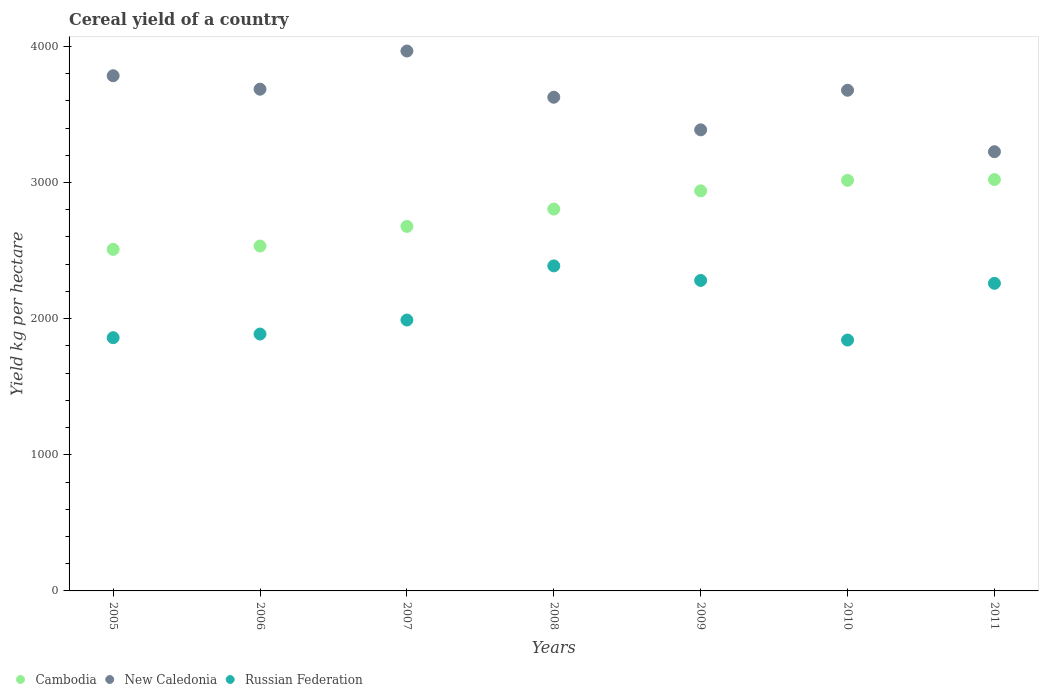What is the total cereal yield in New Caledonia in 2006?
Offer a very short reply. 3685.22. Across all years, what is the maximum total cereal yield in Cambodia?
Offer a terse response. 3021.52. Across all years, what is the minimum total cereal yield in Cambodia?
Provide a succinct answer. 2508.66. What is the total total cereal yield in Russian Federation in the graph?
Keep it short and to the point. 1.45e+04. What is the difference between the total cereal yield in New Caledonia in 2005 and that in 2011?
Offer a very short reply. 557.94. What is the difference between the total cereal yield in Russian Federation in 2006 and the total cereal yield in New Caledonia in 2011?
Your answer should be very brief. -1339.14. What is the average total cereal yield in New Caledonia per year?
Your response must be concise. 3621.57. In the year 2007, what is the difference between the total cereal yield in Cambodia and total cereal yield in Russian Federation?
Keep it short and to the point. 687.45. What is the ratio of the total cereal yield in Russian Federation in 2006 to that in 2010?
Provide a short and direct response. 1.02. Is the difference between the total cereal yield in Cambodia in 2006 and 2009 greater than the difference between the total cereal yield in Russian Federation in 2006 and 2009?
Keep it short and to the point. No. What is the difference between the highest and the second highest total cereal yield in Russian Federation?
Your answer should be compact. 106.78. What is the difference between the highest and the lowest total cereal yield in Russian Federation?
Offer a terse response. 544.64. Is the sum of the total cereal yield in New Caledonia in 2009 and 2010 greater than the maximum total cereal yield in Russian Federation across all years?
Provide a succinct answer. Yes. Is it the case that in every year, the sum of the total cereal yield in New Caledonia and total cereal yield in Cambodia  is greater than the total cereal yield in Russian Federation?
Your answer should be compact. Yes. How many years are there in the graph?
Make the answer very short. 7. Does the graph contain any zero values?
Make the answer very short. No. Does the graph contain grids?
Offer a very short reply. No. Where does the legend appear in the graph?
Your answer should be very brief. Bottom left. How many legend labels are there?
Provide a short and direct response. 3. How are the legend labels stacked?
Keep it short and to the point. Horizontal. What is the title of the graph?
Keep it short and to the point. Cereal yield of a country. What is the label or title of the X-axis?
Your answer should be compact. Years. What is the label or title of the Y-axis?
Provide a short and direct response. Yield kg per hectare. What is the Yield kg per hectare of Cambodia in 2005?
Provide a succinct answer. 2508.66. What is the Yield kg per hectare in New Caledonia in 2005?
Your answer should be compact. 3783.94. What is the Yield kg per hectare in Russian Federation in 2005?
Your answer should be compact. 1860.17. What is the Yield kg per hectare in Cambodia in 2006?
Give a very brief answer. 2533.1. What is the Yield kg per hectare in New Caledonia in 2006?
Offer a very short reply. 3685.22. What is the Yield kg per hectare of Russian Federation in 2006?
Give a very brief answer. 1886.86. What is the Yield kg per hectare in Cambodia in 2007?
Offer a very short reply. 2677.25. What is the Yield kg per hectare of New Caledonia in 2007?
Provide a succinct answer. 3965.54. What is the Yield kg per hectare of Russian Federation in 2007?
Offer a very short reply. 1989.8. What is the Yield kg per hectare in Cambodia in 2008?
Provide a short and direct response. 2804.76. What is the Yield kg per hectare in New Caledonia in 2008?
Your answer should be compact. 3626.16. What is the Yield kg per hectare of Russian Federation in 2008?
Give a very brief answer. 2387.33. What is the Yield kg per hectare of Cambodia in 2009?
Your answer should be very brief. 2938.61. What is the Yield kg per hectare in New Caledonia in 2009?
Your answer should be compact. 3386.68. What is the Yield kg per hectare in Russian Federation in 2009?
Your response must be concise. 2280.55. What is the Yield kg per hectare in Cambodia in 2010?
Provide a short and direct response. 3015.74. What is the Yield kg per hectare in New Caledonia in 2010?
Keep it short and to the point. 3677.45. What is the Yield kg per hectare of Russian Federation in 2010?
Offer a terse response. 1842.69. What is the Yield kg per hectare in Cambodia in 2011?
Keep it short and to the point. 3021.52. What is the Yield kg per hectare of New Caledonia in 2011?
Ensure brevity in your answer.  3226. What is the Yield kg per hectare of Russian Federation in 2011?
Your answer should be compact. 2259.34. Across all years, what is the maximum Yield kg per hectare of Cambodia?
Offer a very short reply. 3021.52. Across all years, what is the maximum Yield kg per hectare of New Caledonia?
Provide a succinct answer. 3965.54. Across all years, what is the maximum Yield kg per hectare of Russian Federation?
Give a very brief answer. 2387.33. Across all years, what is the minimum Yield kg per hectare of Cambodia?
Give a very brief answer. 2508.66. Across all years, what is the minimum Yield kg per hectare in New Caledonia?
Your answer should be compact. 3226. Across all years, what is the minimum Yield kg per hectare in Russian Federation?
Offer a terse response. 1842.69. What is the total Yield kg per hectare in Cambodia in the graph?
Provide a succinct answer. 1.95e+04. What is the total Yield kg per hectare of New Caledonia in the graph?
Your answer should be very brief. 2.54e+04. What is the total Yield kg per hectare in Russian Federation in the graph?
Offer a very short reply. 1.45e+04. What is the difference between the Yield kg per hectare of Cambodia in 2005 and that in 2006?
Provide a short and direct response. -24.45. What is the difference between the Yield kg per hectare in New Caledonia in 2005 and that in 2006?
Offer a very short reply. 98.72. What is the difference between the Yield kg per hectare in Russian Federation in 2005 and that in 2006?
Provide a short and direct response. -26.69. What is the difference between the Yield kg per hectare of Cambodia in 2005 and that in 2007?
Your response must be concise. -168.6. What is the difference between the Yield kg per hectare in New Caledonia in 2005 and that in 2007?
Offer a very short reply. -181.6. What is the difference between the Yield kg per hectare of Russian Federation in 2005 and that in 2007?
Keep it short and to the point. -129.64. What is the difference between the Yield kg per hectare in Cambodia in 2005 and that in 2008?
Your response must be concise. -296.11. What is the difference between the Yield kg per hectare of New Caledonia in 2005 and that in 2008?
Offer a very short reply. 157.78. What is the difference between the Yield kg per hectare in Russian Federation in 2005 and that in 2008?
Offer a very short reply. -527.16. What is the difference between the Yield kg per hectare of Cambodia in 2005 and that in 2009?
Keep it short and to the point. -429.96. What is the difference between the Yield kg per hectare of New Caledonia in 2005 and that in 2009?
Make the answer very short. 397.26. What is the difference between the Yield kg per hectare of Russian Federation in 2005 and that in 2009?
Offer a very short reply. -420.38. What is the difference between the Yield kg per hectare of Cambodia in 2005 and that in 2010?
Your answer should be compact. -507.08. What is the difference between the Yield kg per hectare of New Caledonia in 2005 and that in 2010?
Provide a succinct answer. 106.49. What is the difference between the Yield kg per hectare in Russian Federation in 2005 and that in 2010?
Offer a terse response. 17.47. What is the difference between the Yield kg per hectare in Cambodia in 2005 and that in 2011?
Provide a succinct answer. -512.87. What is the difference between the Yield kg per hectare of New Caledonia in 2005 and that in 2011?
Offer a terse response. 557.94. What is the difference between the Yield kg per hectare in Russian Federation in 2005 and that in 2011?
Provide a succinct answer. -399.17. What is the difference between the Yield kg per hectare in Cambodia in 2006 and that in 2007?
Provide a succinct answer. -144.15. What is the difference between the Yield kg per hectare in New Caledonia in 2006 and that in 2007?
Make the answer very short. -280.32. What is the difference between the Yield kg per hectare in Russian Federation in 2006 and that in 2007?
Give a very brief answer. -102.95. What is the difference between the Yield kg per hectare in Cambodia in 2006 and that in 2008?
Ensure brevity in your answer.  -271.66. What is the difference between the Yield kg per hectare in New Caledonia in 2006 and that in 2008?
Offer a terse response. 59.06. What is the difference between the Yield kg per hectare of Russian Federation in 2006 and that in 2008?
Your response must be concise. -500.47. What is the difference between the Yield kg per hectare in Cambodia in 2006 and that in 2009?
Offer a very short reply. -405.51. What is the difference between the Yield kg per hectare in New Caledonia in 2006 and that in 2009?
Offer a very short reply. 298.54. What is the difference between the Yield kg per hectare in Russian Federation in 2006 and that in 2009?
Offer a terse response. -393.69. What is the difference between the Yield kg per hectare of Cambodia in 2006 and that in 2010?
Keep it short and to the point. -482.64. What is the difference between the Yield kg per hectare of New Caledonia in 2006 and that in 2010?
Provide a short and direct response. 7.76. What is the difference between the Yield kg per hectare of Russian Federation in 2006 and that in 2010?
Your answer should be very brief. 44.16. What is the difference between the Yield kg per hectare in Cambodia in 2006 and that in 2011?
Offer a terse response. -488.42. What is the difference between the Yield kg per hectare of New Caledonia in 2006 and that in 2011?
Provide a short and direct response. 459.22. What is the difference between the Yield kg per hectare of Russian Federation in 2006 and that in 2011?
Keep it short and to the point. -372.48. What is the difference between the Yield kg per hectare in Cambodia in 2007 and that in 2008?
Keep it short and to the point. -127.51. What is the difference between the Yield kg per hectare in New Caledonia in 2007 and that in 2008?
Offer a very short reply. 339.38. What is the difference between the Yield kg per hectare of Russian Federation in 2007 and that in 2008?
Provide a short and direct response. -397.53. What is the difference between the Yield kg per hectare of Cambodia in 2007 and that in 2009?
Offer a terse response. -261.36. What is the difference between the Yield kg per hectare of New Caledonia in 2007 and that in 2009?
Your answer should be compact. 578.86. What is the difference between the Yield kg per hectare of Russian Federation in 2007 and that in 2009?
Keep it short and to the point. -290.75. What is the difference between the Yield kg per hectare in Cambodia in 2007 and that in 2010?
Offer a very short reply. -338.49. What is the difference between the Yield kg per hectare in New Caledonia in 2007 and that in 2010?
Provide a succinct answer. 288.09. What is the difference between the Yield kg per hectare of Russian Federation in 2007 and that in 2010?
Provide a short and direct response. 147.11. What is the difference between the Yield kg per hectare of Cambodia in 2007 and that in 2011?
Provide a short and direct response. -344.27. What is the difference between the Yield kg per hectare of New Caledonia in 2007 and that in 2011?
Keep it short and to the point. 739.54. What is the difference between the Yield kg per hectare in Russian Federation in 2007 and that in 2011?
Provide a short and direct response. -269.53. What is the difference between the Yield kg per hectare in Cambodia in 2008 and that in 2009?
Keep it short and to the point. -133.85. What is the difference between the Yield kg per hectare of New Caledonia in 2008 and that in 2009?
Provide a short and direct response. 239.48. What is the difference between the Yield kg per hectare in Russian Federation in 2008 and that in 2009?
Your answer should be very brief. 106.78. What is the difference between the Yield kg per hectare in Cambodia in 2008 and that in 2010?
Your answer should be very brief. -210.98. What is the difference between the Yield kg per hectare in New Caledonia in 2008 and that in 2010?
Provide a short and direct response. -51.29. What is the difference between the Yield kg per hectare in Russian Federation in 2008 and that in 2010?
Your answer should be compact. 544.64. What is the difference between the Yield kg per hectare in Cambodia in 2008 and that in 2011?
Offer a terse response. -216.76. What is the difference between the Yield kg per hectare of New Caledonia in 2008 and that in 2011?
Your answer should be compact. 400.16. What is the difference between the Yield kg per hectare of Russian Federation in 2008 and that in 2011?
Provide a succinct answer. 127.99. What is the difference between the Yield kg per hectare of Cambodia in 2009 and that in 2010?
Make the answer very short. -77.13. What is the difference between the Yield kg per hectare of New Caledonia in 2009 and that in 2010?
Offer a very short reply. -290.77. What is the difference between the Yield kg per hectare of Russian Federation in 2009 and that in 2010?
Give a very brief answer. 437.86. What is the difference between the Yield kg per hectare in Cambodia in 2009 and that in 2011?
Your answer should be compact. -82.91. What is the difference between the Yield kg per hectare in New Caledonia in 2009 and that in 2011?
Offer a very short reply. 160.68. What is the difference between the Yield kg per hectare in Russian Federation in 2009 and that in 2011?
Your response must be concise. 21.21. What is the difference between the Yield kg per hectare of Cambodia in 2010 and that in 2011?
Keep it short and to the point. -5.78. What is the difference between the Yield kg per hectare of New Caledonia in 2010 and that in 2011?
Your answer should be very brief. 451.45. What is the difference between the Yield kg per hectare of Russian Federation in 2010 and that in 2011?
Your answer should be very brief. -416.64. What is the difference between the Yield kg per hectare of Cambodia in 2005 and the Yield kg per hectare of New Caledonia in 2006?
Offer a very short reply. -1176.56. What is the difference between the Yield kg per hectare in Cambodia in 2005 and the Yield kg per hectare in Russian Federation in 2006?
Offer a very short reply. 621.8. What is the difference between the Yield kg per hectare in New Caledonia in 2005 and the Yield kg per hectare in Russian Federation in 2006?
Your answer should be very brief. 1897.09. What is the difference between the Yield kg per hectare of Cambodia in 2005 and the Yield kg per hectare of New Caledonia in 2007?
Your response must be concise. -1456.88. What is the difference between the Yield kg per hectare of Cambodia in 2005 and the Yield kg per hectare of Russian Federation in 2007?
Give a very brief answer. 518.85. What is the difference between the Yield kg per hectare of New Caledonia in 2005 and the Yield kg per hectare of Russian Federation in 2007?
Your answer should be compact. 1794.14. What is the difference between the Yield kg per hectare of Cambodia in 2005 and the Yield kg per hectare of New Caledonia in 2008?
Your answer should be compact. -1117.5. What is the difference between the Yield kg per hectare of Cambodia in 2005 and the Yield kg per hectare of Russian Federation in 2008?
Make the answer very short. 121.33. What is the difference between the Yield kg per hectare in New Caledonia in 2005 and the Yield kg per hectare in Russian Federation in 2008?
Offer a terse response. 1396.61. What is the difference between the Yield kg per hectare of Cambodia in 2005 and the Yield kg per hectare of New Caledonia in 2009?
Make the answer very short. -878.03. What is the difference between the Yield kg per hectare of Cambodia in 2005 and the Yield kg per hectare of Russian Federation in 2009?
Make the answer very short. 228.11. What is the difference between the Yield kg per hectare of New Caledonia in 2005 and the Yield kg per hectare of Russian Federation in 2009?
Offer a very short reply. 1503.39. What is the difference between the Yield kg per hectare of Cambodia in 2005 and the Yield kg per hectare of New Caledonia in 2010?
Your response must be concise. -1168.8. What is the difference between the Yield kg per hectare in Cambodia in 2005 and the Yield kg per hectare in Russian Federation in 2010?
Offer a terse response. 665.96. What is the difference between the Yield kg per hectare in New Caledonia in 2005 and the Yield kg per hectare in Russian Federation in 2010?
Provide a succinct answer. 1941.25. What is the difference between the Yield kg per hectare in Cambodia in 2005 and the Yield kg per hectare in New Caledonia in 2011?
Offer a terse response. -717.35. What is the difference between the Yield kg per hectare of Cambodia in 2005 and the Yield kg per hectare of Russian Federation in 2011?
Give a very brief answer. 249.32. What is the difference between the Yield kg per hectare of New Caledonia in 2005 and the Yield kg per hectare of Russian Federation in 2011?
Give a very brief answer. 1524.61. What is the difference between the Yield kg per hectare in Cambodia in 2006 and the Yield kg per hectare in New Caledonia in 2007?
Give a very brief answer. -1432.44. What is the difference between the Yield kg per hectare of Cambodia in 2006 and the Yield kg per hectare of Russian Federation in 2007?
Your answer should be very brief. 543.3. What is the difference between the Yield kg per hectare in New Caledonia in 2006 and the Yield kg per hectare in Russian Federation in 2007?
Give a very brief answer. 1695.41. What is the difference between the Yield kg per hectare in Cambodia in 2006 and the Yield kg per hectare in New Caledonia in 2008?
Offer a terse response. -1093.06. What is the difference between the Yield kg per hectare in Cambodia in 2006 and the Yield kg per hectare in Russian Federation in 2008?
Give a very brief answer. 145.77. What is the difference between the Yield kg per hectare of New Caledonia in 2006 and the Yield kg per hectare of Russian Federation in 2008?
Keep it short and to the point. 1297.89. What is the difference between the Yield kg per hectare in Cambodia in 2006 and the Yield kg per hectare in New Caledonia in 2009?
Provide a short and direct response. -853.58. What is the difference between the Yield kg per hectare in Cambodia in 2006 and the Yield kg per hectare in Russian Federation in 2009?
Provide a short and direct response. 252.55. What is the difference between the Yield kg per hectare in New Caledonia in 2006 and the Yield kg per hectare in Russian Federation in 2009?
Provide a short and direct response. 1404.67. What is the difference between the Yield kg per hectare in Cambodia in 2006 and the Yield kg per hectare in New Caledonia in 2010?
Provide a short and direct response. -1144.35. What is the difference between the Yield kg per hectare in Cambodia in 2006 and the Yield kg per hectare in Russian Federation in 2010?
Keep it short and to the point. 690.41. What is the difference between the Yield kg per hectare in New Caledonia in 2006 and the Yield kg per hectare in Russian Federation in 2010?
Provide a short and direct response. 1842.53. What is the difference between the Yield kg per hectare of Cambodia in 2006 and the Yield kg per hectare of New Caledonia in 2011?
Your answer should be very brief. -692.9. What is the difference between the Yield kg per hectare in Cambodia in 2006 and the Yield kg per hectare in Russian Federation in 2011?
Keep it short and to the point. 273.76. What is the difference between the Yield kg per hectare of New Caledonia in 2006 and the Yield kg per hectare of Russian Federation in 2011?
Your response must be concise. 1425.88. What is the difference between the Yield kg per hectare in Cambodia in 2007 and the Yield kg per hectare in New Caledonia in 2008?
Make the answer very short. -948.91. What is the difference between the Yield kg per hectare of Cambodia in 2007 and the Yield kg per hectare of Russian Federation in 2008?
Offer a very short reply. 289.92. What is the difference between the Yield kg per hectare in New Caledonia in 2007 and the Yield kg per hectare in Russian Federation in 2008?
Your answer should be compact. 1578.21. What is the difference between the Yield kg per hectare in Cambodia in 2007 and the Yield kg per hectare in New Caledonia in 2009?
Give a very brief answer. -709.43. What is the difference between the Yield kg per hectare of Cambodia in 2007 and the Yield kg per hectare of Russian Federation in 2009?
Give a very brief answer. 396.7. What is the difference between the Yield kg per hectare in New Caledonia in 2007 and the Yield kg per hectare in Russian Federation in 2009?
Your response must be concise. 1684.99. What is the difference between the Yield kg per hectare of Cambodia in 2007 and the Yield kg per hectare of New Caledonia in 2010?
Your response must be concise. -1000.2. What is the difference between the Yield kg per hectare in Cambodia in 2007 and the Yield kg per hectare in Russian Federation in 2010?
Provide a short and direct response. 834.56. What is the difference between the Yield kg per hectare of New Caledonia in 2007 and the Yield kg per hectare of Russian Federation in 2010?
Provide a succinct answer. 2122.85. What is the difference between the Yield kg per hectare in Cambodia in 2007 and the Yield kg per hectare in New Caledonia in 2011?
Your answer should be compact. -548.75. What is the difference between the Yield kg per hectare in Cambodia in 2007 and the Yield kg per hectare in Russian Federation in 2011?
Make the answer very short. 417.92. What is the difference between the Yield kg per hectare of New Caledonia in 2007 and the Yield kg per hectare of Russian Federation in 2011?
Offer a terse response. 1706.2. What is the difference between the Yield kg per hectare of Cambodia in 2008 and the Yield kg per hectare of New Caledonia in 2009?
Your answer should be compact. -581.92. What is the difference between the Yield kg per hectare in Cambodia in 2008 and the Yield kg per hectare in Russian Federation in 2009?
Provide a succinct answer. 524.21. What is the difference between the Yield kg per hectare in New Caledonia in 2008 and the Yield kg per hectare in Russian Federation in 2009?
Provide a succinct answer. 1345.61. What is the difference between the Yield kg per hectare in Cambodia in 2008 and the Yield kg per hectare in New Caledonia in 2010?
Give a very brief answer. -872.69. What is the difference between the Yield kg per hectare of Cambodia in 2008 and the Yield kg per hectare of Russian Federation in 2010?
Keep it short and to the point. 962.07. What is the difference between the Yield kg per hectare of New Caledonia in 2008 and the Yield kg per hectare of Russian Federation in 2010?
Ensure brevity in your answer.  1783.47. What is the difference between the Yield kg per hectare of Cambodia in 2008 and the Yield kg per hectare of New Caledonia in 2011?
Your answer should be very brief. -421.24. What is the difference between the Yield kg per hectare of Cambodia in 2008 and the Yield kg per hectare of Russian Federation in 2011?
Provide a short and direct response. 545.42. What is the difference between the Yield kg per hectare in New Caledonia in 2008 and the Yield kg per hectare in Russian Federation in 2011?
Your response must be concise. 1366.82. What is the difference between the Yield kg per hectare in Cambodia in 2009 and the Yield kg per hectare in New Caledonia in 2010?
Provide a short and direct response. -738.84. What is the difference between the Yield kg per hectare of Cambodia in 2009 and the Yield kg per hectare of Russian Federation in 2010?
Offer a terse response. 1095.92. What is the difference between the Yield kg per hectare in New Caledonia in 2009 and the Yield kg per hectare in Russian Federation in 2010?
Your answer should be compact. 1543.99. What is the difference between the Yield kg per hectare in Cambodia in 2009 and the Yield kg per hectare in New Caledonia in 2011?
Offer a terse response. -287.39. What is the difference between the Yield kg per hectare of Cambodia in 2009 and the Yield kg per hectare of Russian Federation in 2011?
Your answer should be very brief. 679.27. What is the difference between the Yield kg per hectare of New Caledonia in 2009 and the Yield kg per hectare of Russian Federation in 2011?
Provide a short and direct response. 1127.35. What is the difference between the Yield kg per hectare of Cambodia in 2010 and the Yield kg per hectare of New Caledonia in 2011?
Give a very brief answer. -210.26. What is the difference between the Yield kg per hectare in Cambodia in 2010 and the Yield kg per hectare in Russian Federation in 2011?
Provide a succinct answer. 756.4. What is the difference between the Yield kg per hectare of New Caledonia in 2010 and the Yield kg per hectare of Russian Federation in 2011?
Provide a short and direct response. 1418.12. What is the average Yield kg per hectare in Cambodia per year?
Your answer should be compact. 2785.66. What is the average Yield kg per hectare of New Caledonia per year?
Ensure brevity in your answer.  3621.57. What is the average Yield kg per hectare in Russian Federation per year?
Offer a terse response. 2072.39. In the year 2005, what is the difference between the Yield kg per hectare of Cambodia and Yield kg per hectare of New Caledonia?
Provide a succinct answer. -1275.29. In the year 2005, what is the difference between the Yield kg per hectare of Cambodia and Yield kg per hectare of Russian Federation?
Your answer should be very brief. 648.49. In the year 2005, what is the difference between the Yield kg per hectare in New Caledonia and Yield kg per hectare in Russian Federation?
Offer a terse response. 1923.78. In the year 2006, what is the difference between the Yield kg per hectare in Cambodia and Yield kg per hectare in New Caledonia?
Make the answer very short. -1152.12. In the year 2006, what is the difference between the Yield kg per hectare of Cambodia and Yield kg per hectare of Russian Federation?
Offer a terse response. 646.24. In the year 2006, what is the difference between the Yield kg per hectare of New Caledonia and Yield kg per hectare of Russian Federation?
Your response must be concise. 1798.36. In the year 2007, what is the difference between the Yield kg per hectare in Cambodia and Yield kg per hectare in New Caledonia?
Your answer should be very brief. -1288.29. In the year 2007, what is the difference between the Yield kg per hectare in Cambodia and Yield kg per hectare in Russian Federation?
Keep it short and to the point. 687.45. In the year 2007, what is the difference between the Yield kg per hectare in New Caledonia and Yield kg per hectare in Russian Federation?
Ensure brevity in your answer.  1975.74. In the year 2008, what is the difference between the Yield kg per hectare of Cambodia and Yield kg per hectare of New Caledonia?
Provide a short and direct response. -821.4. In the year 2008, what is the difference between the Yield kg per hectare in Cambodia and Yield kg per hectare in Russian Federation?
Make the answer very short. 417.43. In the year 2008, what is the difference between the Yield kg per hectare in New Caledonia and Yield kg per hectare in Russian Federation?
Keep it short and to the point. 1238.83. In the year 2009, what is the difference between the Yield kg per hectare of Cambodia and Yield kg per hectare of New Caledonia?
Your response must be concise. -448.07. In the year 2009, what is the difference between the Yield kg per hectare of Cambodia and Yield kg per hectare of Russian Federation?
Offer a very short reply. 658.06. In the year 2009, what is the difference between the Yield kg per hectare of New Caledonia and Yield kg per hectare of Russian Federation?
Offer a terse response. 1106.13. In the year 2010, what is the difference between the Yield kg per hectare in Cambodia and Yield kg per hectare in New Caledonia?
Make the answer very short. -661.72. In the year 2010, what is the difference between the Yield kg per hectare in Cambodia and Yield kg per hectare in Russian Federation?
Make the answer very short. 1173.05. In the year 2010, what is the difference between the Yield kg per hectare in New Caledonia and Yield kg per hectare in Russian Federation?
Make the answer very short. 1834.76. In the year 2011, what is the difference between the Yield kg per hectare of Cambodia and Yield kg per hectare of New Caledonia?
Give a very brief answer. -204.48. In the year 2011, what is the difference between the Yield kg per hectare of Cambodia and Yield kg per hectare of Russian Federation?
Make the answer very short. 762.18. In the year 2011, what is the difference between the Yield kg per hectare in New Caledonia and Yield kg per hectare in Russian Federation?
Provide a succinct answer. 966.66. What is the ratio of the Yield kg per hectare in Cambodia in 2005 to that in 2006?
Keep it short and to the point. 0.99. What is the ratio of the Yield kg per hectare of New Caledonia in 2005 to that in 2006?
Make the answer very short. 1.03. What is the ratio of the Yield kg per hectare of Russian Federation in 2005 to that in 2006?
Provide a short and direct response. 0.99. What is the ratio of the Yield kg per hectare of Cambodia in 2005 to that in 2007?
Offer a very short reply. 0.94. What is the ratio of the Yield kg per hectare of New Caledonia in 2005 to that in 2007?
Your response must be concise. 0.95. What is the ratio of the Yield kg per hectare of Russian Federation in 2005 to that in 2007?
Make the answer very short. 0.93. What is the ratio of the Yield kg per hectare in Cambodia in 2005 to that in 2008?
Ensure brevity in your answer.  0.89. What is the ratio of the Yield kg per hectare in New Caledonia in 2005 to that in 2008?
Your response must be concise. 1.04. What is the ratio of the Yield kg per hectare in Russian Federation in 2005 to that in 2008?
Offer a terse response. 0.78. What is the ratio of the Yield kg per hectare of Cambodia in 2005 to that in 2009?
Provide a succinct answer. 0.85. What is the ratio of the Yield kg per hectare in New Caledonia in 2005 to that in 2009?
Keep it short and to the point. 1.12. What is the ratio of the Yield kg per hectare in Russian Federation in 2005 to that in 2009?
Your answer should be very brief. 0.82. What is the ratio of the Yield kg per hectare in Cambodia in 2005 to that in 2010?
Your answer should be compact. 0.83. What is the ratio of the Yield kg per hectare in Russian Federation in 2005 to that in 2010?
Offer a terse response. 1.01. What is the ratio of the Yield kg per hectare in Cambodia in 2005 to that in 2011?
Offer a very short reply. 0.83. What is the ratio of the Yield kg per hectare in New Caledonia in 2005 to that in 2011?
Offer a terse response. 1.17. What is the ratio of the Yield kg per hectare of Russian Federation in 2005 to that in 2011?
Offer a terse response. 0.82. What is the ratio of the Yield kg per hectare of Cambodia in 2006 to that in 2007?
Offer a very short reply. 0.95. What is the ratio of the Yield kg per hectare of New Caledonia in 2006 to that in 2007?
Ensure brevity in your answer.  0.93. What is the ratio of the Yield kg per hectare in Russian Federation in 2006 to that in 2007?
Your answer should be very brief. 0.95. What is the ratio of the Yield kg per hectare in Cambodia in 2006 to that in 2008?
Ensure brevity in your answer.  0.9. What is the ratio of the Yield kg per hectare of New Caledonia in 2006 to that in 2008?
Ensure brevity in your answer.  1.02. What is the ratio of the Yield kg per hectare in Russian Federation in 2006 to that in 2008?
Offer a terse response. 0.79. What is the ratio of the Yield kg per hectare in Cambodia in 2006 to that in 2009?
Provide a succinct answer. 0.86. What is the ratio of the Yield kg per hectare of New Caledonia in 2006 to that in 2009?
Make the answer very short. 1.09. What is the ratio of the Yield kg per hectare of Russian Federation in 2006 to that in 2009?
Make the answer very short. 0.83. What is the ratio of the Yield kg per hectare of Cambodia in 2006 to that in 2010?
Give a very brief answer. 0.84. What is the ratio of the Yield kg per hectare in New Caledonia in 2006 to that in 2010?
Your answer should be very brief. 1. What is the ratio of the Yield kg per hectare of Cambodia in 2006 to that in 2011?
Your answer should be very brief. 0.84. What is the ratio of the Yield kg per hectare of New Caledonia in 2006 to that in 2011?
Your answer should be compact. 1.14. What is the ratio of the Yield kg per hectare of Russian Federation in 2006 to that in 2011?
Offer a terse response. 0.84. What is the ratio of the Yield kg per hectare of Cambodia in 2007 to that in 2008?
Provide a succinct answer. 0.95. What is the ratio of the Yield kg per hectare of New Caledonia in 2007 to that in 2008?
Offer a terse response. 1.09. What is the ratio of the Yield kg per hectare of Russian Federation in 2007 to that in 2008?
Make the answer very short. 0.83. What is the ratio of the Yield kg per hectare of Cambodia in 2007 to that in 2009?
Provide a short and direct response. 0.91. What is the ratio of the Yield kg per hectare of New Caledonia in 2007 to that in 2009?
Provide a succinct answer. 1.17. What is the ratio of the Yield kg per hectare in Russian Federation in 2007 to that in 2009?
Make the answer very short. 0.87. What is the ratio of the Yield kg per hectare of Cambodia in 2007 to that in 2010?
Ensure brevity in your answer.  0.89. What is the ratio of the Yield kg per hectare in New Caledonia in 2007 to that in 2010?
Ensure brevity in your answer.  1.08. What is the ratio of the Yield kg per hectare in Russian Federation in 2007 to that in 2010?
Provide a short and direct response. 1.08. What is the ratio of the Yield kg per hectare in Cambodia in 2007 to that in 2011?
Ensure brevity in your answer.  0.89. What is the ratio of the Yield kg per hectare in New Caledonia in 2007 to that in 2011?
Ensure brevity in your answer.  1.23. What is the ratio of the Yield kg per hectare in Russian Federation in 2007 to that in 2011?
Give a very brief answer. 0.88. What is the ratio of the Yield kg per hectare of Cambodia in 2008 to that in 2009?
Offer a terse response. 0.95. What is the ratio of the Yield kg per hectare in New Caledonia in 2008 to that in 2009?
Your answer should be very brief. 1.07. What is the ratio of the Yield kg per hectare in Russian Federation in 2008 to that in 2009?
Provide a short and direct response. 1.05. What is the ratio of the Yield kg per hectare in New Caledonia in 2008 to that in 2010?
Provide a short and direct response. 0.99. What is the ratio of the Yield kg per hectare of Russian Federation in 2008 to that in 2010?
Offer a terse response. 1.3. What is the ratio of the Yield kg per hectare in Cambodia in 2008 to that in 2011?
Your answer should be compact. 0.93. What is the ratio of the Yield kg per hectare in New Caledonia in 2008 to that in 2011?
Your answer should be very brief. 1.12. What is the ratio of the Yield kg per hectare in Russian Federation in 2008 to that in 2011?
Keep it short and to the point. 1.06. What is the ratio of the Yield kg per hectare in Cambodia in 2009 to that in 2010?
Provide a succinct answer. 0.97. What is the ratio of the Yield kg per hectare of New Caledonia in 2009 to that in 2010?
Your response must be concise. 0.92. What is the ratio of the Yield kg per hectare of Russian Federation in 2009 to that in 2010?
Ensure brevity in your answer.  1.24. What is the ratio of the Yield kg per hectare in Cambodia in 2009 to that in 2011?
Offer a terse response. 0.97. What is the ratio of the Yield kg per hectare in New Caledonia in 2009 to that in 2011?
Provide a succinct answer. 1.05. What is the ratio of the Yield kg per hectare in Russian Federation in 2009 to that in 2011?
Offer a terse response. 1.01. What is the ratio of the Yield kg per hectare in Cambodia in 2010 to that in 2011?
Your response must be concise. 1. What is the ratio of the Yield kg per hectare in New Caledonia in 2010 to that in 2011?
Offer a terse response. 1.14. What is the ratio of the Yield kg per hectare in Russian Federation in 2010 to that in 2011?
Make the answer very short. 0.82. What is the difference between the highest and the second highest Yield kg per hectare in Cambodia?
Your answer should be compact. 5.78. What is the difference between the highest and the second highest Yield kg per hectare of New Caledonia?
Keep it short and to the point. 181.6. What is the difference between the highest and the second highest Yield kg per hectare of Russian Federation?
Keep it short and to the point. 106.78. What is the difference between the highest and the lowest Yield kg per hectare of Cambodia?
Keep it short and to the point. 512.87. What is the difference between the highest and the lowest Yield kg per hectare of New Caledonia?
Make the answer very short. 739.54. What is the difference between the highest and the lowest Yield kg per hectare of Russian Federation?
Make the answer very short. 544.64. 